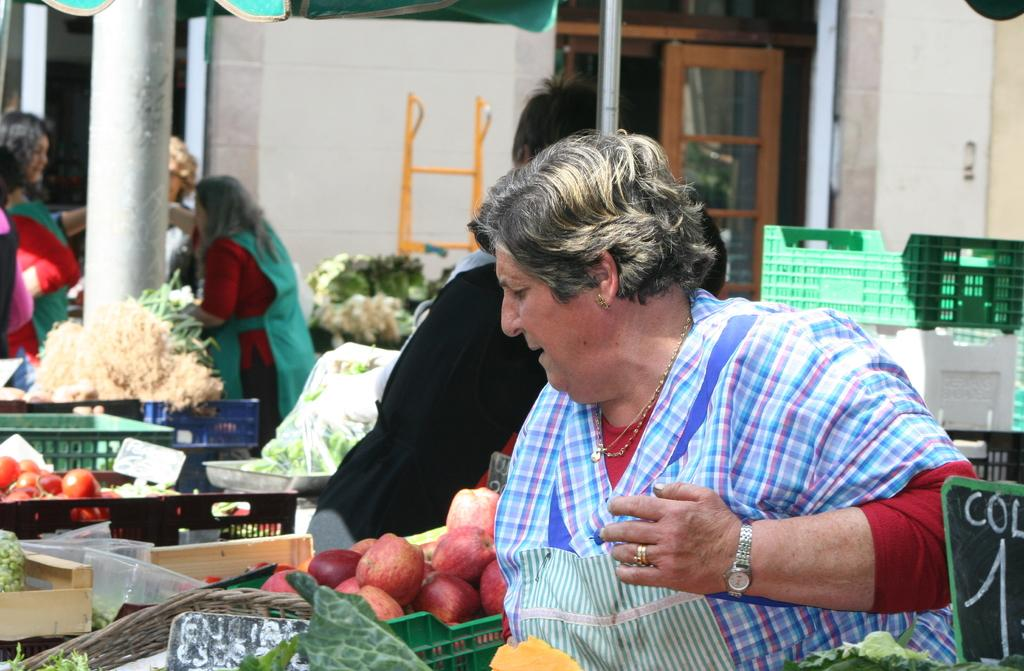Who or what is present in the image? There are people in the image. What types of food items can be seen in the image? There are fruits and vegetables in the image. How are the fruits and vegetables arranged or stored in the image? The fruits and vegetables are kept in baskets. What type of stew is being prepared by the chickens in the image? There are no chickens or stew present in the image. How many cows can be seen grazing in the background of the image? There are no cows visible in the image. 